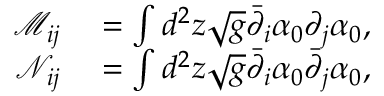<formula> <loc_0><loc_0><loc_500><loc_500>\begin{array} { r l } { \mathcal { M } _ { i j } } & = \int d ^ { 2 } z \sqrt { g } \bar { \partial } _ { i } \alpha _ { 0 } \partial _ { j } \alpha _ { 0 } , } \\ { \mathcal { N } _ { i j } } & = \int d ^ { 2 } z \sqrt { g } \bar { \partial } _ { i } \alpha _ { 0 } \bar { \partial } _ { j } \alpha _ { 0 } , } \end{array}</formula> 